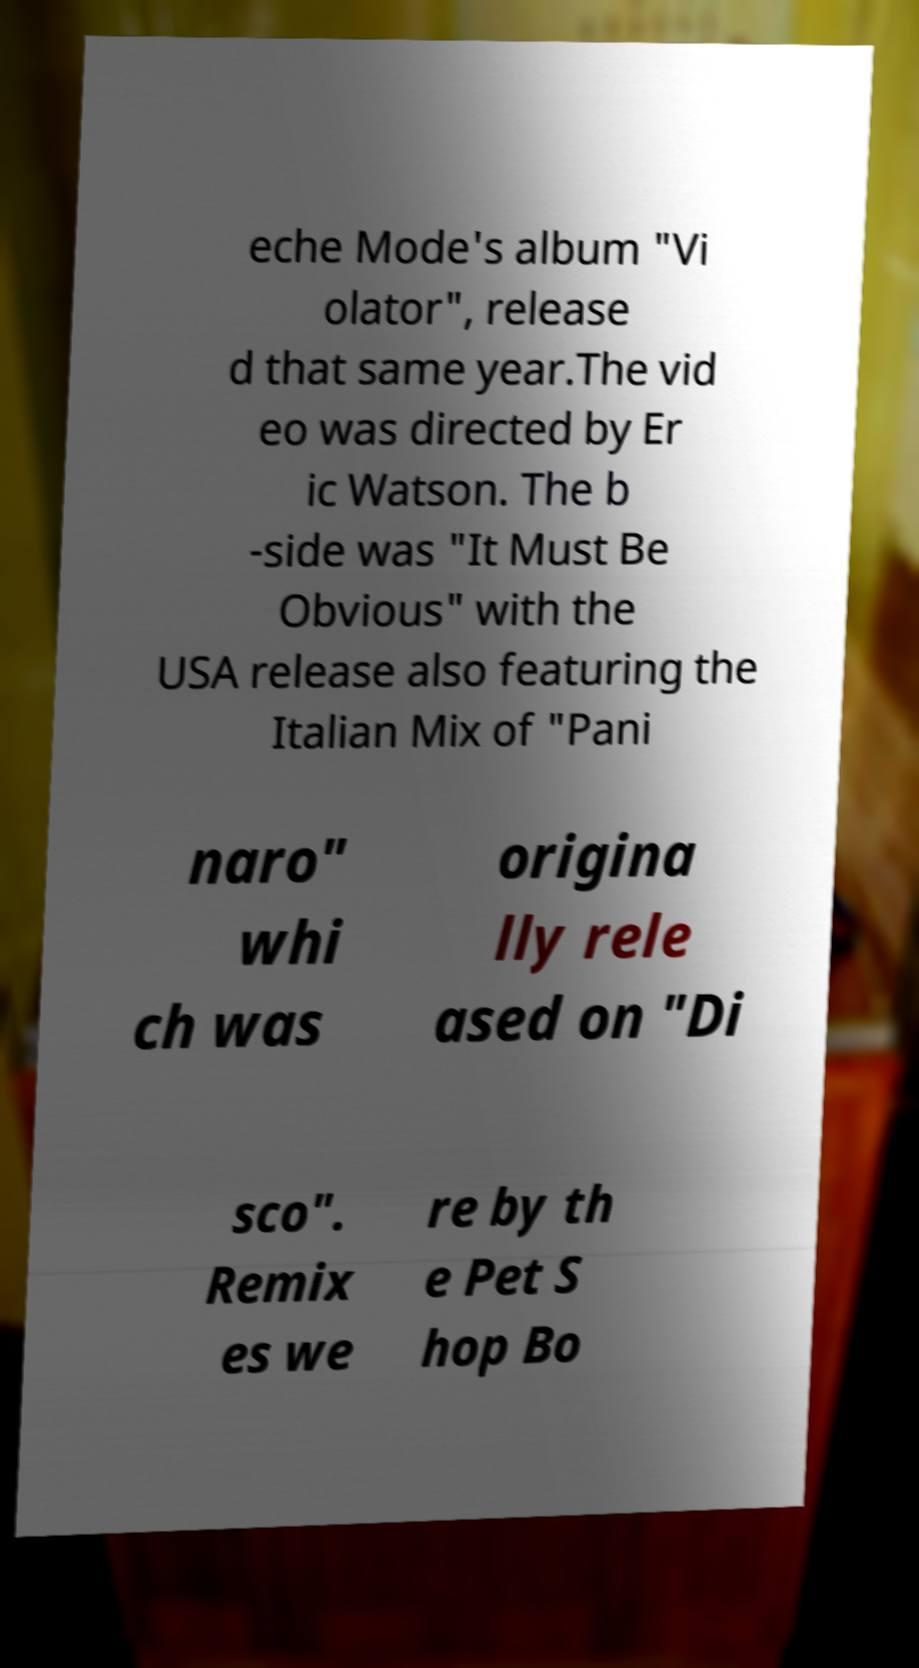Please identify and transcribe the text found in this image. eche Mode's album "Vi olator", release d that same year.The vid eo was directed by Er ic Watson. The b -side was "It Must Be Obvious" with the USA release also featuring the Italian Mix of "Pani naro" whi ch was origina lly rele ased on "Di sco". Remix es we re by th e Pet S hop Bo 